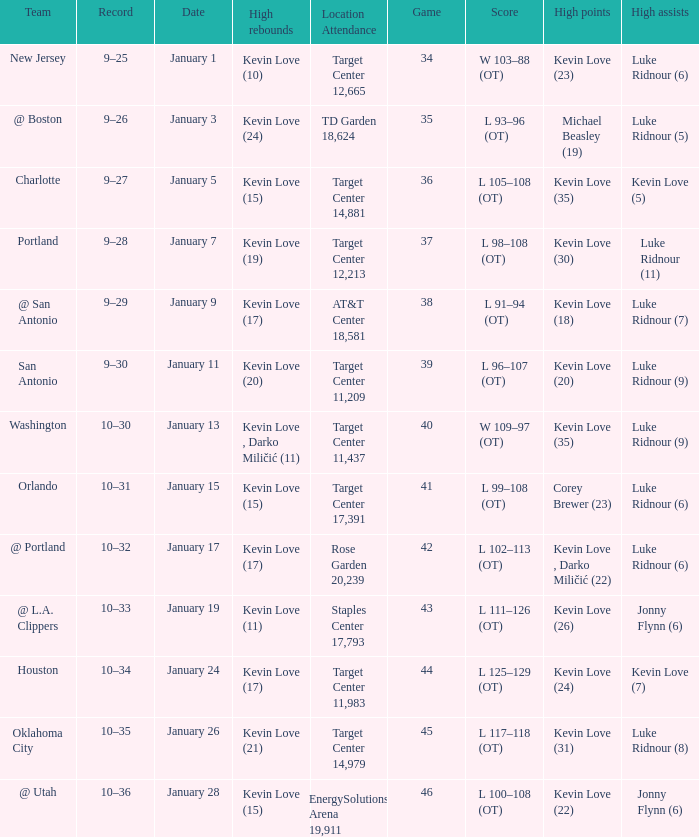How many times did kevin love (22) have the high points? 1.0. 